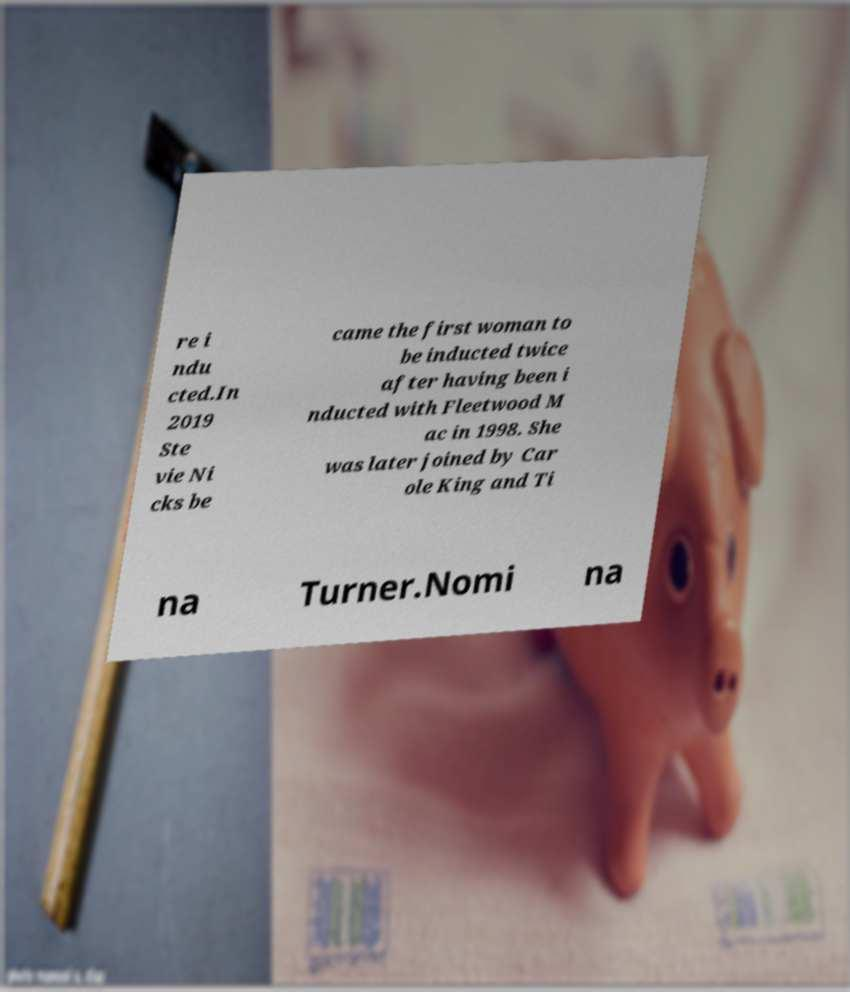Could you assist in decoding the text presented in this image and type it out clearly? re i ndu cted.In 2019 Ste vie Ni cks be came the first woman to be inducted twice after having been i nducted with Fleetwood M ac in 1998. She was later joined by Car ole King and Ti na Turner.Nomi na 